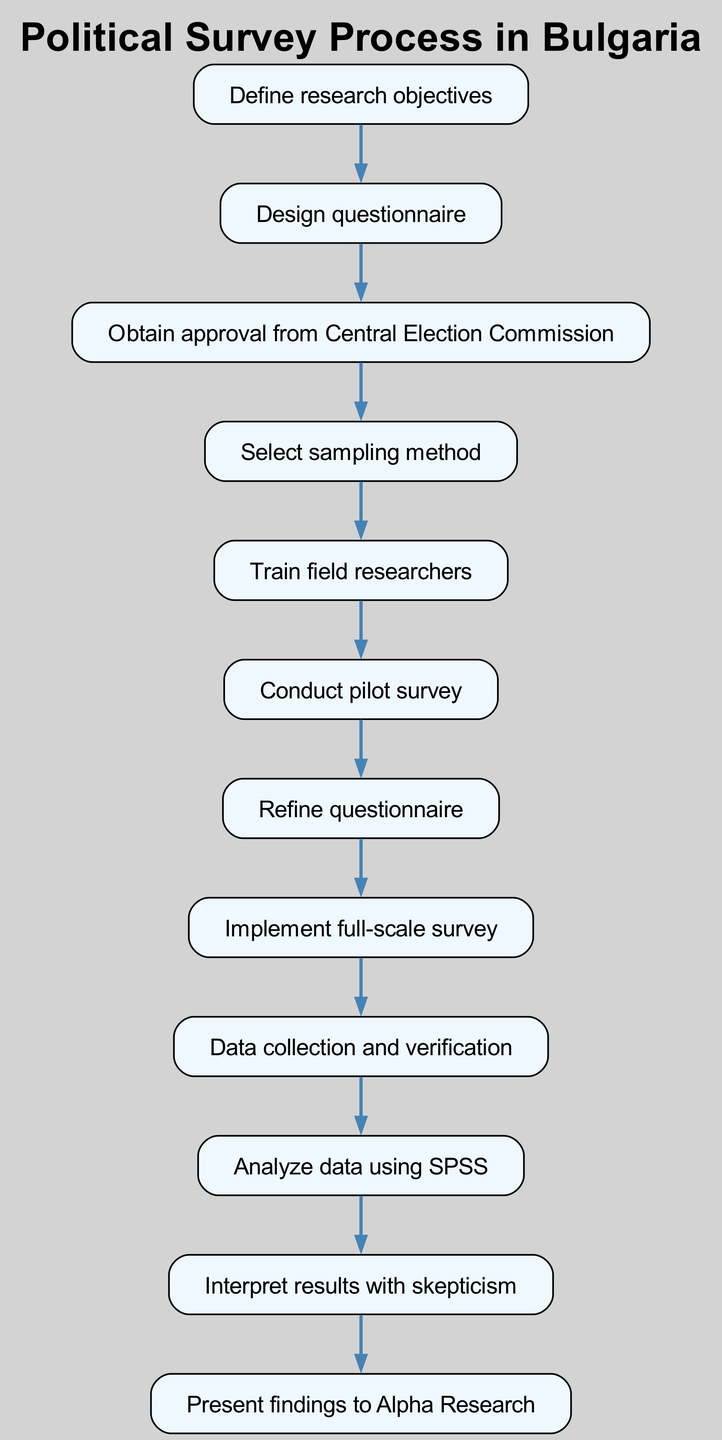What is the first step in the process? The first step is to "Define research objectives." This is the beginning of the flowchart, indicating that defining what the survey seeks to achieve is essential to the subsequent steps.
Answer: Define research objectives How many steps are in the survey process? By counting the nodes in the flowchart, there are a total of 12 steps in the process, including the initial step and the final step.
Answer: 12 What follows after obtaining approval from the Central Election Commission? After obtaining approval, the next step is to "Select sampling method." This indicates the continuation of the process toward implementing the survey once necessary approvals are secured.
Answer: Select sampling method Which step involves data analysis? The step that involves data analysis is "Analyze data using SPSS." This indicates that the collected data will be analyzed using the SPSS software, an important step in processing the survey results.
Answer: Analyze data using SPSS What is the last step in the process? The last step in the process is to "Present findings to Alpha Research," marking the point at which the results are communicated to the stakeholders involved in the survey.
Answer: Present findings to Alpha Research Which step comes immediately after conducting the pilot survey? The step that comes immediately after conducting the pilot survey is "Refine questionnaire." This indicates that modifications to the questionnaire will be made based on the pilot results before proceeding with the full survey.
Answer: Refine questionnaire What is required before conducting the full-scale survey? Before conducting the full-scale survey, "Refine questionnaire" is required. This step ensures that any necessary adjustments are made to the questionnaire based on pilot feedback to improve clarity and effectiveness.
Answer: Refine questionnaire Explain the relationship between "Train field researchers" and "Conduct pilot survey". "Train field researchers" is a prerequisite for "Conduct pilot survey." It implies that researchers must be adequately trained in how to conduct the survey effectively prior to testing the survey process with a pilot survey.
Answer: Train field researchers What step involves data verification? The step that involves data verification is "Data collection and verification." This indicates that collected data will not only be gathered but also verified to ensure accuracy before analysis.
Answer: Data collection and verification 